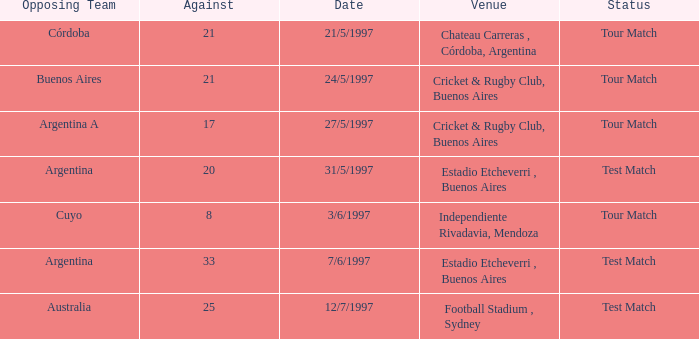Which venue has an against value larger than 21 and had Argentina as an opposing team. Estadio Etcheverri , Buenos Aires. Parse the table in full. {'header': ['Opposing Team', 'Against', 'Date', 'Venue', 'Status'], 'rows': [['Córdoba', '21', '21/5/1997', 'Chateau Carreras , Córdoba, Argentina', 'Tour Match'], ['Buenos Aires', '21', '24/5/1997', 'Cricket & Rugby Club, Buenos Aires', 'Tour Match'], ['Argentina A', '17', '27/5/1997', 'Cricket & Rugby Club, Buenos Aires', 'Tour Match'], ['Argentina', '20', '31/5/1997', 'Estadio Etcheverri , Buenos Aires', 'Test Match'], ['Cuyo', '8', '3/6/1997', 'Independiente Rivadavia, Mendoza', 'Tour Match'], ['Argentina', '33', '7/6/1997', 'Estadio Etcheverri , Buenos Aires', 'Test Match'], ['Australia', '25', '12/7/1997', 'Football Stadium , Sydney', 'Test Match']]} 